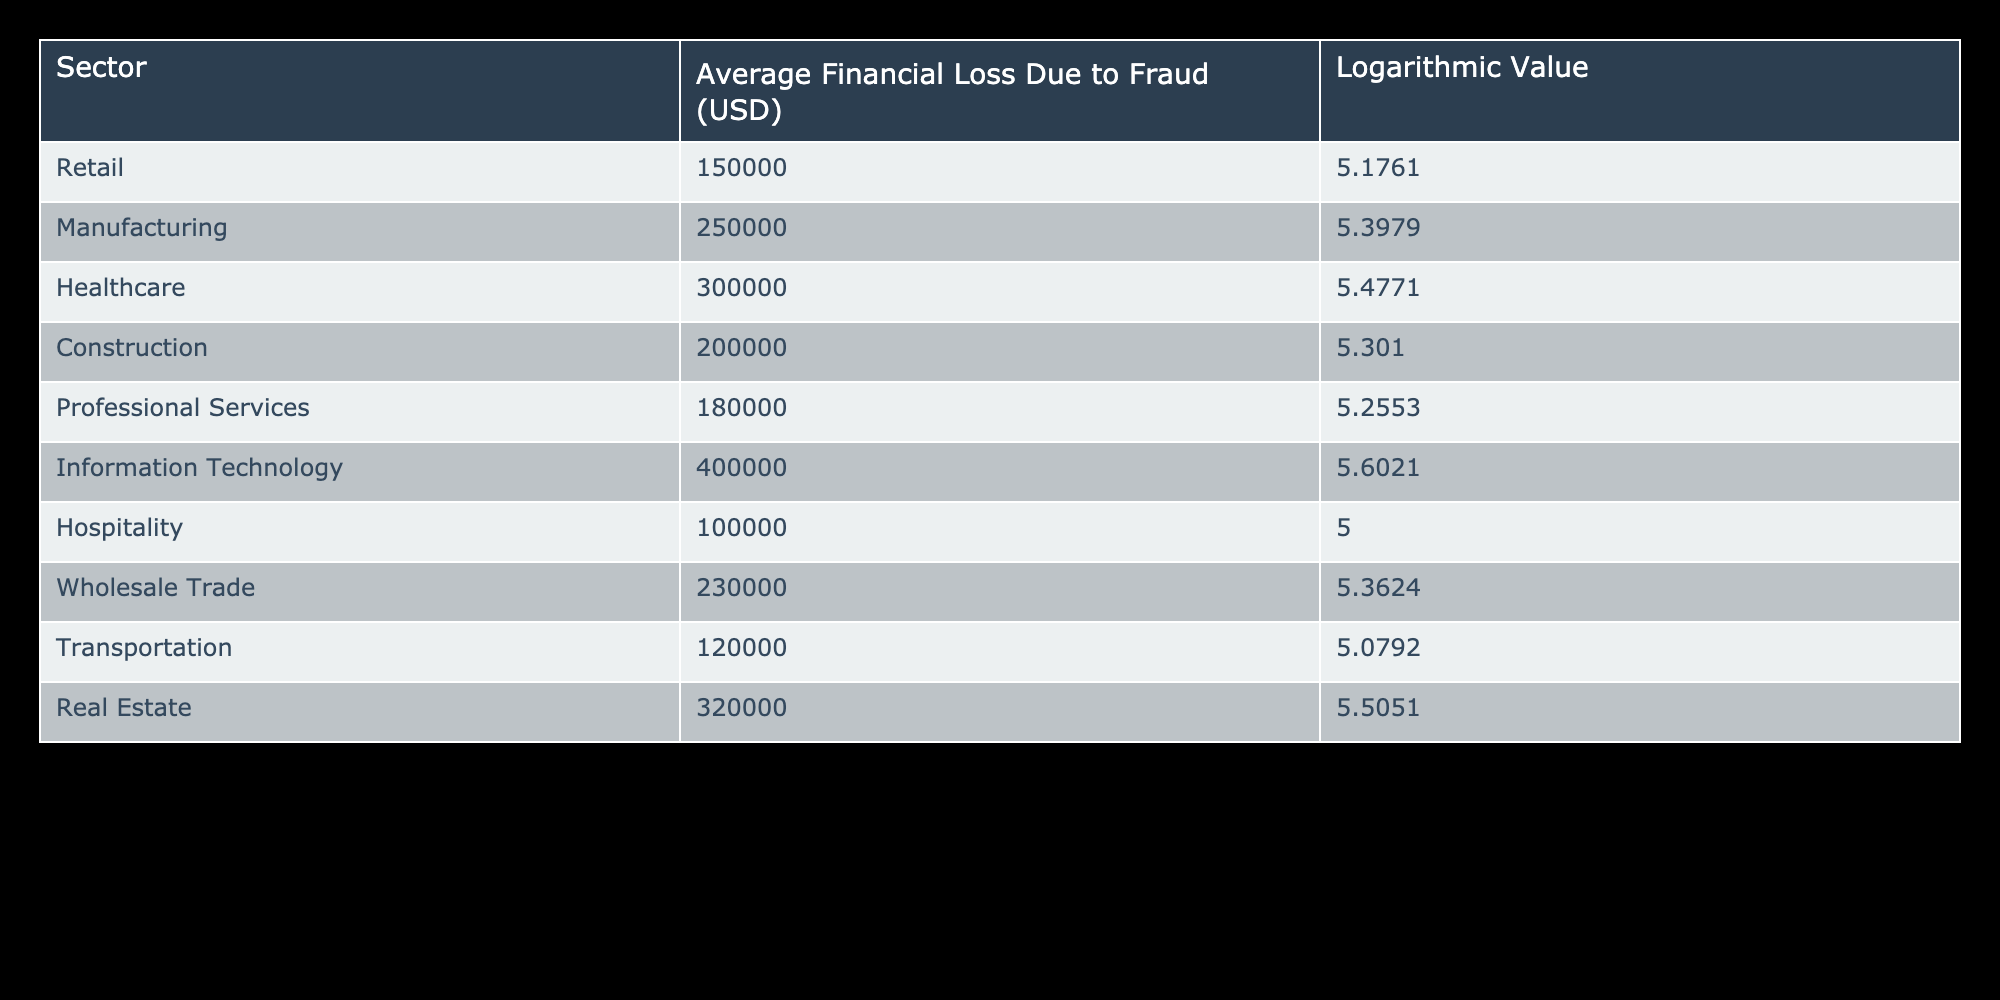What is the average financial loss due to fraud in the healthcare sector? The table shows the average financial loss specifically for the healthcare sector as 300000 USD. This is directly retrieved from the data without needing any calculations.
Answer: 300000 USD Which sector has the highest average financial loss due to fraud? By reviewing the table, the Information Technology sector shows the highest financial loss at 400000 USD, which is greater than all other sectors listed.
Answer: Information Technology What is the total average financial loss due to fraud across all sectors? Adding the average financial losses for all sectors: 150000 + 250000 + 300000 + 200000 + 180000 + 400000 + 100000 + 230000 + 120000 + 320000 gives a total of 2250000. Thus, the total is 2250000 USD.
Answer: 2250000 USD Is the average financial loss due to fraud higher in real estate than in construction? The table shows real estate losses at 320000 USD and construction losses at 200000 USD. Since 320000 is greater than 200000, it is true that real estate has a higher financial loss.
Answer: Yes What is the difference in average financial loss due to fraud between the retail and wholesale trade sectors? The average loss for retail is 150000 USD, and for wholesale trade, it is 230000 USD. The difference is calculated as 230000 - 150000 = 80000 USD.
Answer: 80000 USD Which sectors have an average financial loss below 200000 USD? From the table, the sectors with losses below 200000 USD are retail with 150000 USD and hospitality with 100000 USD. Both are identified directly from their values.
Answer: Retail and Hospitality What is the logarithmic value of the average financial loss due to fraud in the manufacturing sector? The table indicates that the manufacturing sector has an average financial loss logarithmic value of 5.3979. This value is provided in the table directly under that sector's data.
Answer: 5.3979 If you combine the average financial losses of healthcare and real estate, what would the total be? The average financial loss for healthcare is 300000 USD and for real estate, it is 320000 USD. Adding these together, 300000 + 320000 equals 620000 USD. Therefore, the combined loss is 620000 USD.
Answer: 620000 USD Are financial losses due to fraud uniform across all sectors? The table reveals varying financial loss figures for different sectors, indicating that sectors like Information Technology and Healthcare have significantly higher losses compared to sectors like Hospitality and Retail. Therefore, losses are not uniform.
Answer: No 